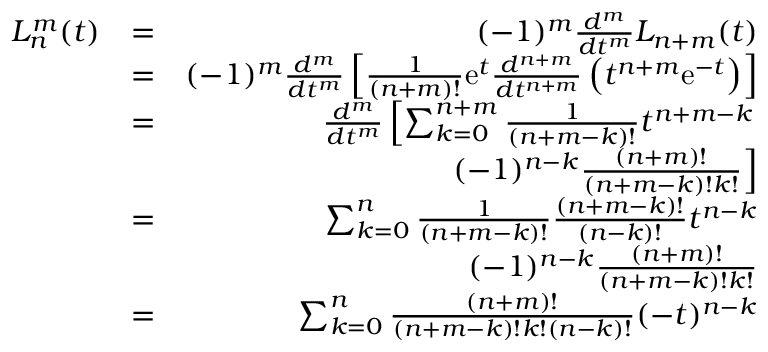Convert formula to latex. <formula><loc_0><loc_0><loc_500><loc_500>\begin{array} { r l r } { L _ { n } ^ { m } ( t ) } & { = } & { ( - 1 ) ^ { m } \frac { d ^ { m } } { d t ^ { m } } L _ { n + m } ( t ) } \\ & { = } & { ( - 1 ) ^ { m } \frac { d ^ { m } } { d t ^ { m } } \left [ \frac { 1 } { ( n + m ) ! } e ^ { t } \frac { d ^ { n + m } } { d t ^ { n + m } } \left ( t ^ { n + m } e ^ { - t } \right ) \right ] } \\ & { = } & { \frac { d ^ { m } } { d t ^ { m } } \left [ \sum _ { k = 0 } ^ { n + m } \frac { 1 } { ( n + m - k ) ! } t ^ { n + m - k } } \\ & { \quad l e f t . ( - 1 ) ^ { n - k } \frac { ( n + m ) ! } { ( n + m - k ) ! k ! } \right ] } \\ & { = } & { \sum _ { k = 0 } ^ { n } \frac { 1 } { ( n + m - k ) ! } \frac { ( n + m - k ) ! } { ( n - k ) ! } t ^ { n - k } } \\ & { \ \ ( - 1 ) ^ { n - k } \frac { ( n + m ) ! } { ( n + m - k ) ! k ! } } \\ & { = } & { \sum _ { k = 0 } ^ { n } \frac { ( n + m ) ! } { ( n + m - k ) ! k ! ( n - k ) ! } ( - t ) ^ { n - k } } \end{array}</formula> 